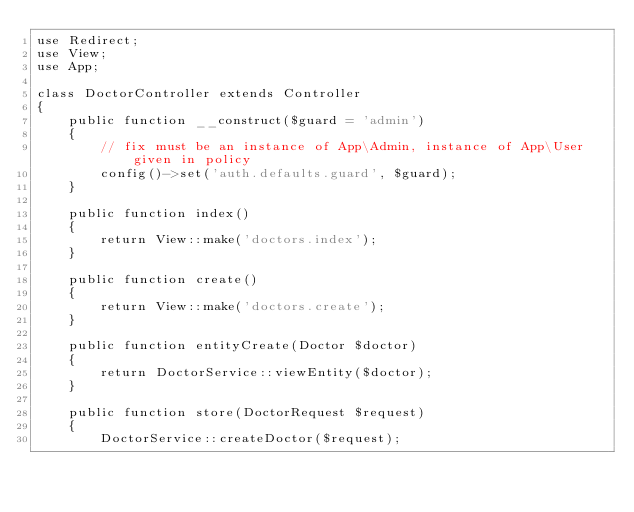<code> <loc_0><loc_0><loc_500><loc_500><_PHP_>use Redirect;
use View;
use App;

class DoctorController extends Controller
{
    public function __construct($guard = 'admin')
    {
        // fix must be an instance of App\Admin, instance of App\User given in policy
        config()->set('auth.defaults.guard', $guard);
    }

    public function index()
    {
        return View::make('doctors.index');
    }

    public function create()
    {
        return View::make('doctors.create');
    }

    public function entityCreate(Doctor $doctor)
    {
        return DoctorService::viewEntity($doctor);
    }

    public function store(DoctorRequest $request)
    {
        DoctorService::createDoctor($request);</code> 